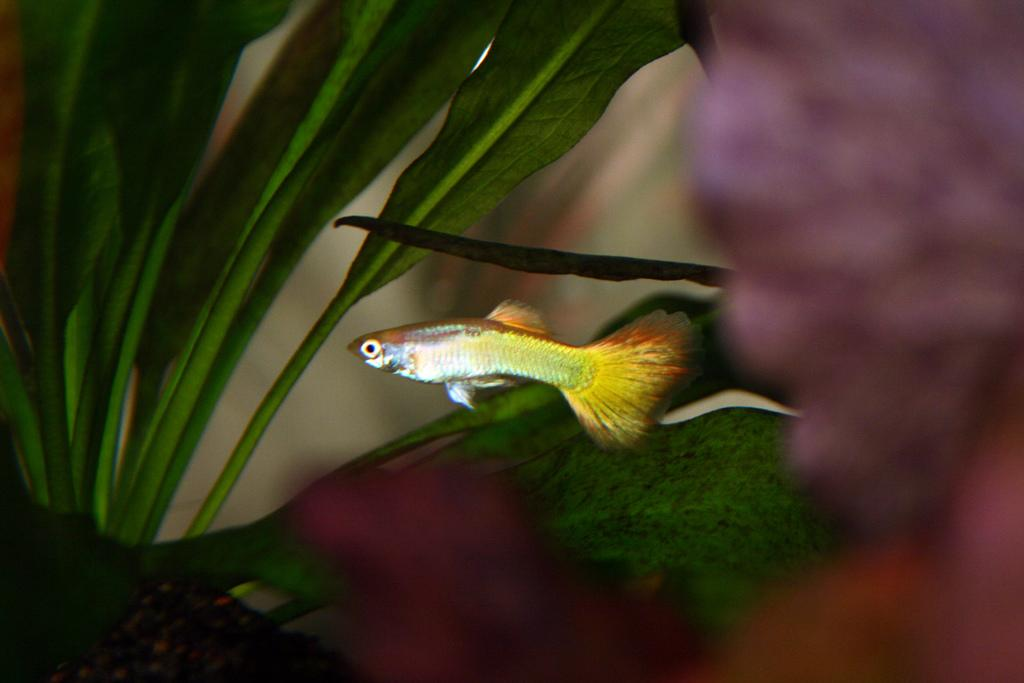What is inside the water in the image? There is a fish inside the water in the image. Which direction is the fish facing? The fish is facing towards the left side. What can be seen on the left side of the image? There is a plant on the left side of the image. How would you describe the background of the image? The background of the image is blurred. What type of business is being conducted in the image? There is no indication of any business being conducted in the image; it primarily features a fish in water with a plant on the left side and a blurred background. 